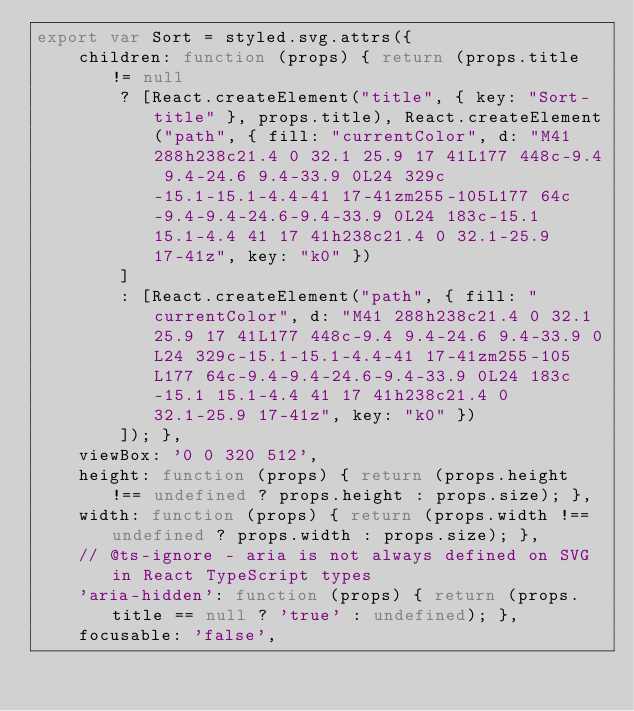Convert code to text. <code><loc_0><loc_0><loc_500><loc_500><_JavaScript_>export var Sort = styled.svg.attrs({
    children: function (props) { return (props.title != null
        ? [React.createElement("title", { key: "Sort-title" }, props.title), React.createElement("path", { fill: "currentColor", d: "M41 288h238c21.4 0 32.1 25.9 17 41L177 448c-9.4 9.4-24.6 9.4-33.9 0L24 329c-15.1-15.1-4.4-41 17-41zm255-105L177 64c-9.4-9.4-24.6-9.4-33.9 0L24 183c-15.1 15.1-4.4 41 17 41h238c21.4 0 32.1-25.9 17-41z", key: "k0" })
        ]
        : [React.createElement("path", { fill: "currentColor", d: "M41 288h238c21.4 0 32.1 25.9 17 41L177 448c-9.4 9.4-24.6 9.4-33.9 0L24 329c-15.1-15.1-4.4-41 17-41zm255-105L177 64c-9.4-9.4-24.6-9.4-33.9 0L24 183c-15.1 15.1-4.4 41 17 41h238c21.4 0 32.1-25.9 17-41z", key: "k0" })
        ]); },
    viewBox: '0 0 320 512',
    height: function (props) { return (props.height !== undefined ? props.height : props.size); },
    width: function (props) { return (props.width !== undefined ? props.width : props.size); },
    // @ts-ignore - aria is not always defined on SVG in React TypeScript types
    'aria-hidden': function (props) { return (props.title == null ? 'true' : undefined); },
    focusable: 'false',</code> 